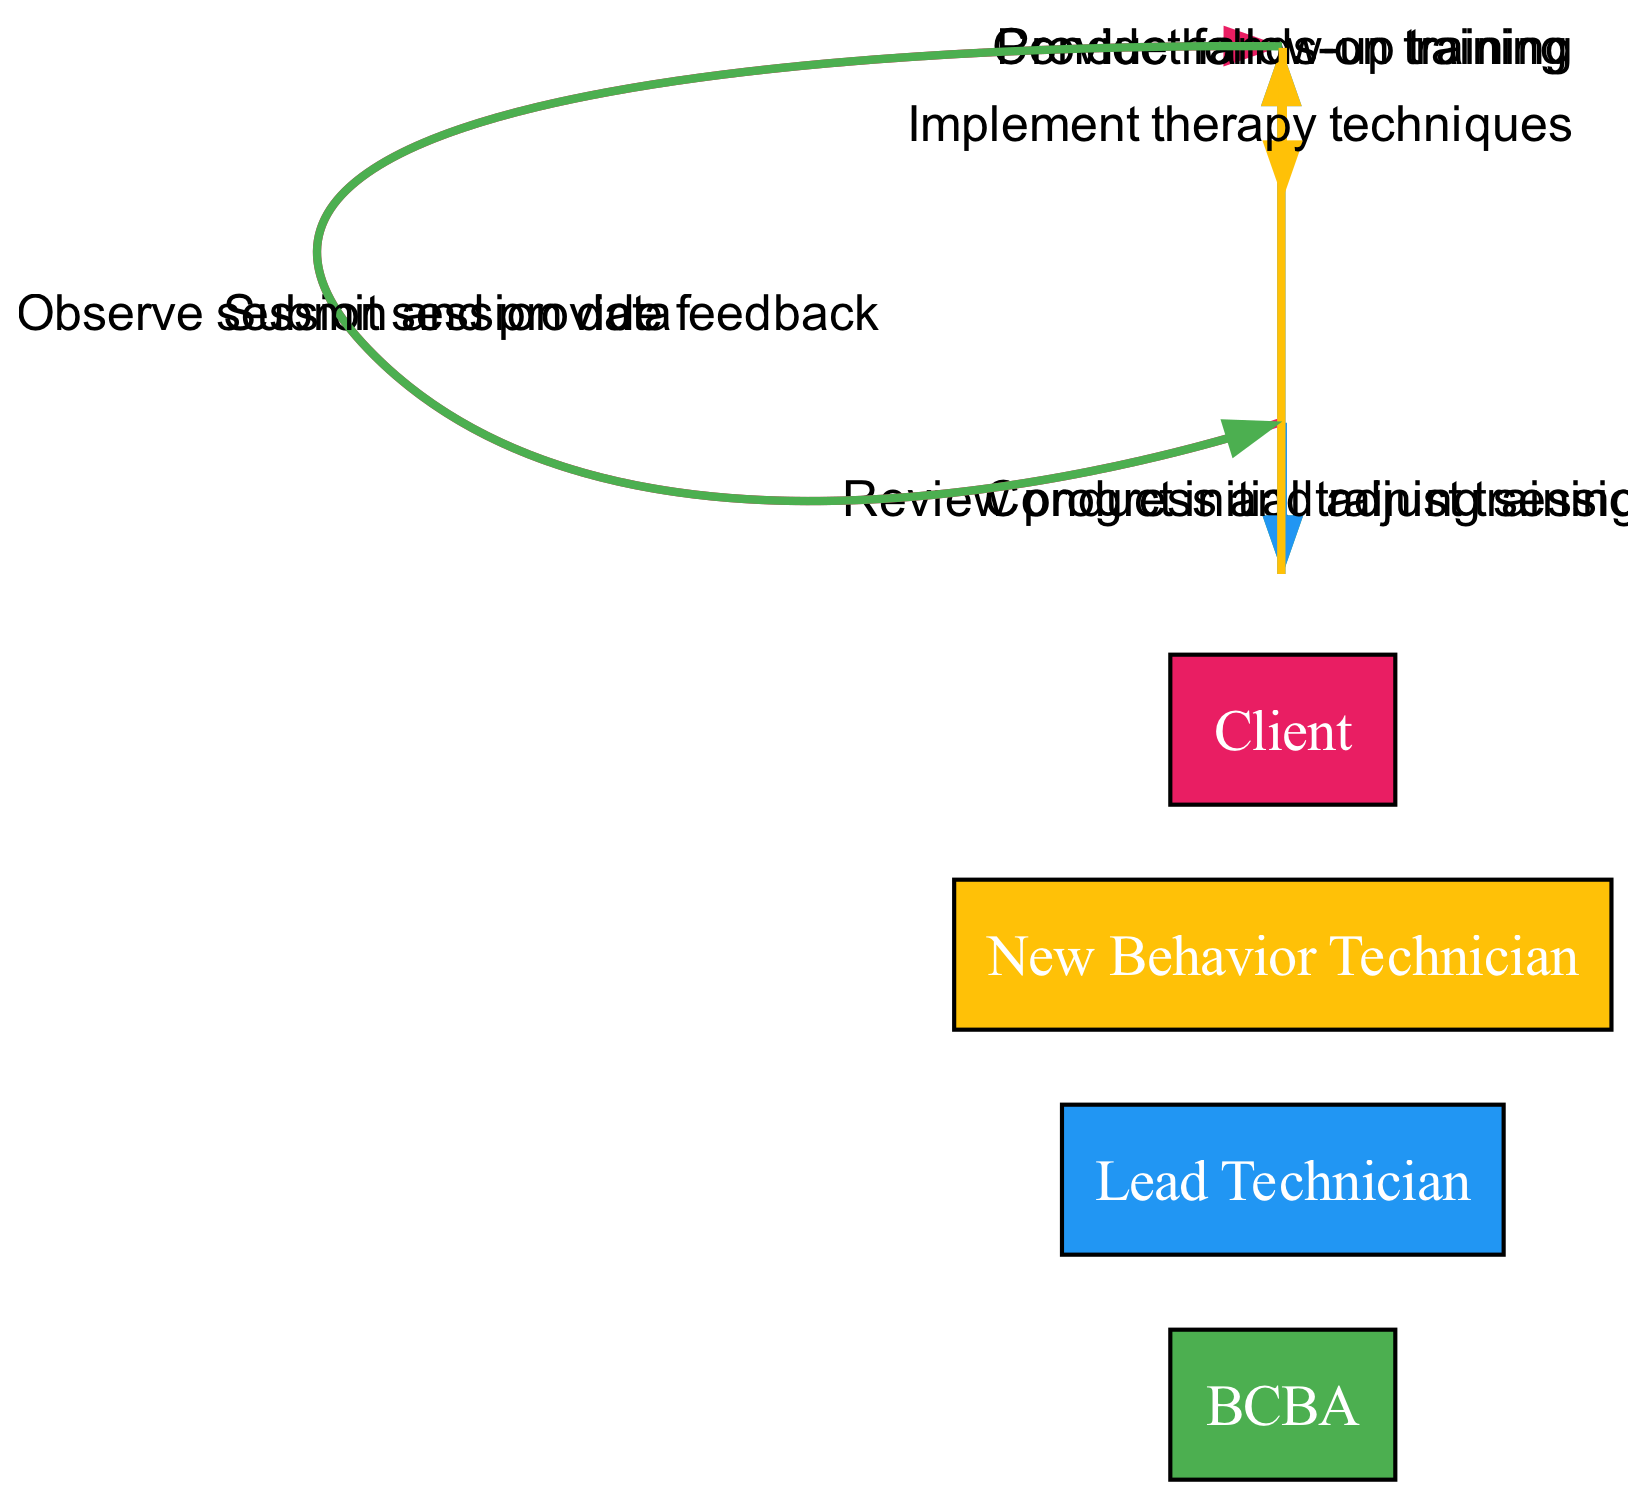What is the first action taken by the BCBA? The first action noted in the diagram is "Conduct initial training session" from the BCBA to the Lead Technician. This is the starting point of the sequence of interactions between the participants.
Answer: Conduct initial training session Who receives hands-on training? The message indicates that the "New Behavior Technician" receives hands-on training from the "Lead Technician." This relationship clearly specifies the direction of the training.
Answer: New Behavior Technician How many participants are involved in the sequence? The diagram lists four distinct participants: BCBA, Lead Technician, New Behavior Technician, and Client. Counting these reveals the total number of participants in the process illustrated.
Answer: 4 What is the last action in the sequence? The last action in the sequence is "Conduct follow-up training," which is conducted by the Lead Technician for the New Behavior Technician. This indicates the closure of the training loop in the process.
Answer: Conduct follow-up training Which participant submits session data? According to the diagram, the New Behavior Technician is responsible for submitting session data to the BCBA. This clearly shows the flow of information in the sequence.
Answer: New Behavior Technician What feedback is provided to the New Behavior Technician? The BCBA observes the session and provides feedback to the New Behavior Technician after their implementation of therapy techniques. This shows the supervisory role of the BCBA in the sequence.
Answer: Observe session and provide feedback How does the Lead Technician contribute to the process after the initial training? The Lead Technician contributes by conducting follow-up training with the New Behavior Technician after reviewing their progress, demonstrating an ongoing role in the training process.
Answer: Conduct follow-up training Which two actions happen directly sequentially from the BCBA to the Lead Technician? The BCBA first conducts an initial training session with the Lead Technician, followed by reviewing progress and adjusting training, creating a direct sequence of actions involving the BCBA and Lead Technician.
Answer: Conduct initial training session, Review progress and adjust training 